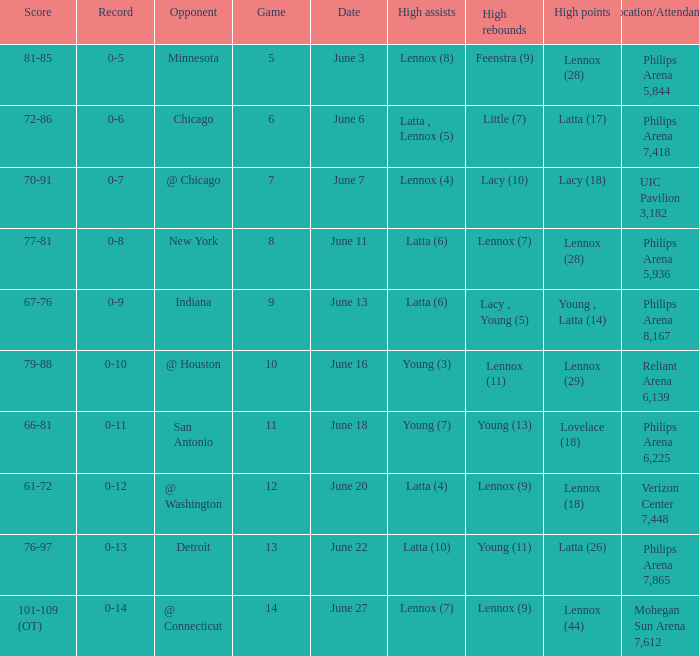What stadium hosted the June 7 game and how many visitors were there? UIC Pavilion 3,182. Parse the full table. {'header': ['Score', 'Record', 'Opponent', 'Game', 'Date', 'High assists', 'High rebounds', 'High points', 'Location/Attendance'], 'rows': [['81-85', '0-5', 'Minnesota', '5', 'June 3', 'Lennox (8)', 'Feenstra (9)', 'Lennox (28)', 'Philips Arena 5,844'], ['72-86', '0-6', 'Chicago', '6', 'June 6', 'Latta , Lennox (5)', 'Little (7)', 'Latta (17)', 'Philips Arena 7,418'], ['70-91', '0-7', '@ Chicago', '7', 'June 7', 'Lennox (4)', 'Lacy (10)', 'Lacy (18)', 'UIC Pavilion 3,182'], ['77-81', '0-8', 'New York', '8', 'June 11', 'Latta (6)', 'Lennox (7)', 'Lennox (28)', 'Philips Arena 5,936'], ['67-76', '0-9', 'Indiana', '9', 'June 13', 'Latta (6)', 'Lacy , Young (5)', 'Young , Latta (14)', 'Philips Arena 8,167'], ['79-88', '0-10', '@ Houston', '10', 'June 16', 'Young (3)', 'Lennox (11)', 'Lennox (29)', 'Reliant Arena 6,139'], ['66-81', '0-11', 'San Antonio', '11', 'June 18', 'Young (7)', 'Young (13)', 'Lovelace (18)', 'Philips Arena 6,225'], ['61-72', '0-12', '@ Washington', '12', 'June 20', 'Latta (4)', 'Lennox (9)', 'Lennox (18)', 'Verizon Center 7,448'], ['76-97', '0-13', 'Detroit', '13', 'June 22', 'Latta (10)', 'Young (11)', 'Latta (26)', 'Philips Arena 7,865'], ['101-109 (OT)', '0-14', '@ Connecticut', '14', 'June 27', 'Lennox (7)', 'Lennox (9)', 'Lennox (44)', 'Mohegan Sun Arena 7,612']]} 